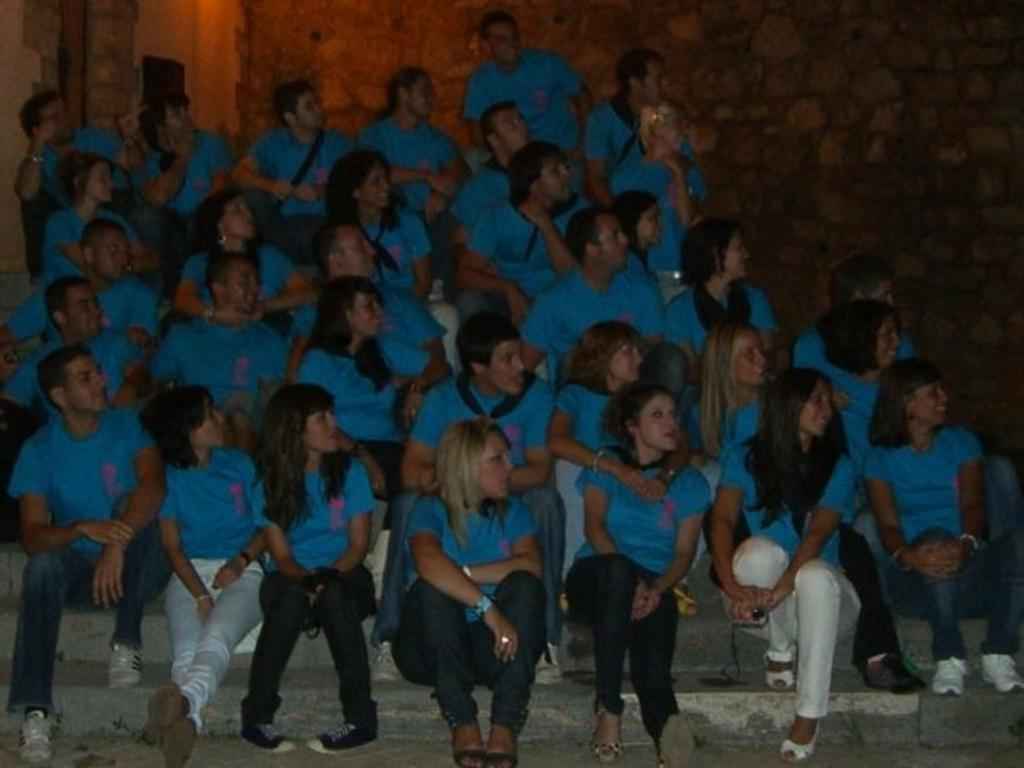What is the main subject of the image? The main subject of the image is a group of people. Where are the people in the image? The people are sitting on stairs. What are the people wearing in the image? The people are wearing blue T-shirts. What else can be seen in the background of the image? There is a wall in the image. What type of straw is being used by the people in the image? There is no straw present in the image. How does the sneeze of one person affect the others in the image? There is no sneeze or indication of a sneeze in the image. 